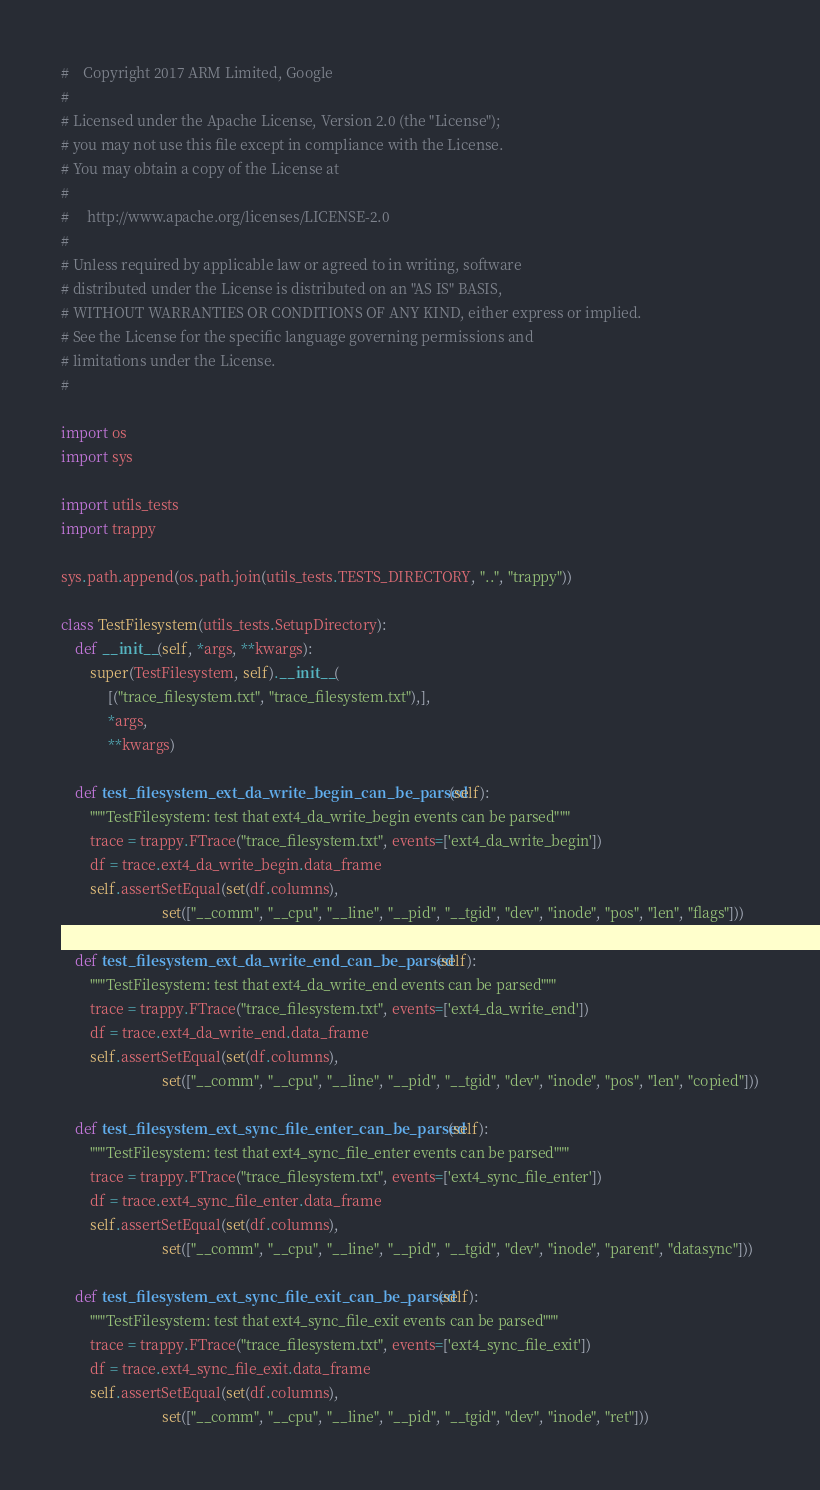<code> <loc_0><loc_0><loc_500><loc_500><_Python_>#    Copyright 2017 ARM Limited, Google
#
# Licensed under the Apache License, Version 2.0 (the "License");
# you may not use this file except in compliance with the License.
# You may obtain a copy of the License at
#
#     http://www.apache.org/licenses/LICENSE-2.0
#
# Unless required by applicable law or agreed to in writing, software
# distributed under the License is distributed on an "AS IS" BASIS,
# WITHOUT WARRANTIES OR CONDITIONS OF ANY KIND, either express or implied.
# See the License for the specific language governing permissions and
# limitations under the License.
#

import os
import sys

import utils_tests
import trappy

sys.path.append(os.path.join(utils_tests.TESTS_DIRECTORY, "..", "trappy"))

class TestFilesystem(utils_tests.SetupDirectory):
    def __init__(self, *args, **kwargs):
        super(TestFilesystem, self).__init__(
             [("trace_filesystem.txt", "trace_filesystem.txt"),],
             *args,
             **kwargs)

    def test_filesystem_ext_da_write_begin_can_be_parsed(self):
        """TestFilesystem: test that ext4_da_write_begin events can be parsed"""
        trace = trappy.FTrace("trace_filesystem.txt", events=['ext4_da_write_begin'])
        df = trace.ext4_da_write_begin.data_frame
        self.assertSetEqual(set(df.columns),
                            set(["__comm", "__cpu", "__line", "__pid", "__tgid", "dev", "inode", "pos", "len", "flags"]))

    def test_filesystem_ext_da_write_end_can_be_parsed(self):
        """TestFilesystem: test that ext4_da_write_end events can be parsed"""
        trace = trappy.FTrace("trace_filesystem.txt", events=['ext4_da_write_end'])
        df = trace.ext4_da_write_end.data_frame
        self.assertSetEqual(set(df.columns),
                            set(["__comm", "__cpu", "__line", "__pid", "__tgid", "dev", "inode", "pos", "len", "copied"]))

    def test_filesystem_ext_sync_file_enter_can_be_parsed(self):
        """TestFilesystem: test that ext4_sync_file_enter events can be parsed"""
        trace = trappy.FTrace("trace_filesystem.txt", events=['ext4_sync_file_enter'])
        df = trace.ext4_sync_file_enter.data_frame
        self.assertSetEqual(set(df.columns),
                            set(["__comm", "__cpu", "__line", "__pid", "__tgid", "dev", "inode", "parent", "datasync"]))

    def test_filesystem_ext_sync_file_exit_can_be_parsed(self):
        """TestFilesystem: test that ext4_sync_file_exit events can be parsed"""
        trace = trappy.FTrace("trace_filesystem.txt", events=['ext4_sync_file_exit'])
        df = trace.ext4_sync_file_exit.data_frame
        self.assertSetEqual(set(df.columns),
                            set(["__comm", "__cpu", "__line", "__pid", "__tgid", "dev", "inode", "ret"]))
</code> 